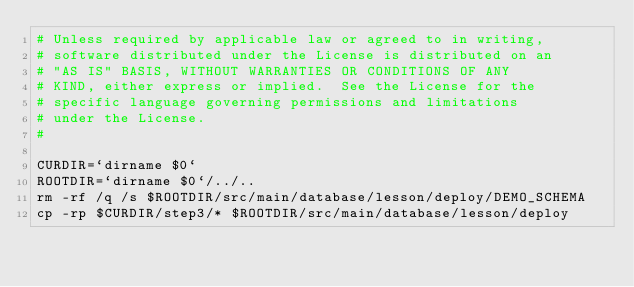Convert code to text. <code><loc_0><loc_0><loc_500><loc_500><_Bash_># Unless required by applicable law or agreed to in writing,
# software distributed under the License is distributed on an
# "AS IS" BASIS, WITHOUT WARRANTIES OR CONDITIONS OF ANY
# KIND, either express or implied.  See the License for the
# specific language governing permissions and limitations
# under the License.
#

CURDIR=`dirname $0`
ROOTDIR=`dirname $0`/../..
rm -rf /q /s $ROOTDIR/src/main/database/lesson/deploy/DEMO_SCHEMA
cp -rp $CURDIR/step3/* $ROOTDIR/src/main/database/lesson/deploy
</code> 